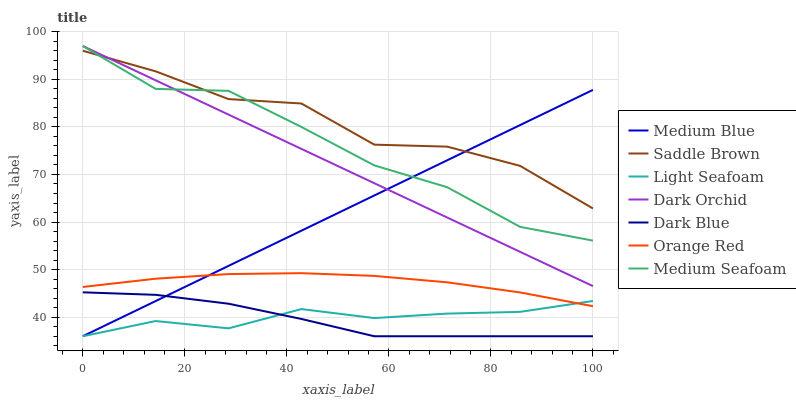Does Dark Blue have the minimum area under the curve?
Answer yes or no. Yes. Does Saddle Brown have the maximum area under the curve?
Answer yes or no. Yes. Does Dark Orchid have the minimum area under the curve?
Answer yes or no. No. Does Dark Orchid have the maximum area under the curve?
Answer yes or no. No. Is Medium Blue the smoothest?
Answer yes or no. Yes. Is Saddle Brown the roughest?
Answer yes or no. Yes. Is Dark Orchid the smoothest?
Answer yes or no. No. Is Dark Orchid the roughest?
Answer yes or no. No. Does Medium Blue have the lowest value?
Answer yes or no. Yes. Does Dark Orchid have the lowest value?
Answer yes or no. No. Does Medium Seafoam have the highest value?
Answer yes or no. Yes. Does Orange Red have the highest value?
Answer yes or no. No. Is Dark Blue less than Medium Seafoam?
Answer yes or no. Yes. Is Saddle Brown greater than Light Seafoam?
Answer yes or no. Yes. Does Light Seafoam intersect Dark Blue?
Answer yes or no. Yes. Is Light Seafoam less than Dark Blue?
Answer yes or no. No. Is Light Seafoam greater than Dark Blue?
Answer yes or no. No. Does Dark Blue intersect Medium Seafoam?
Answer yes or no. No. 